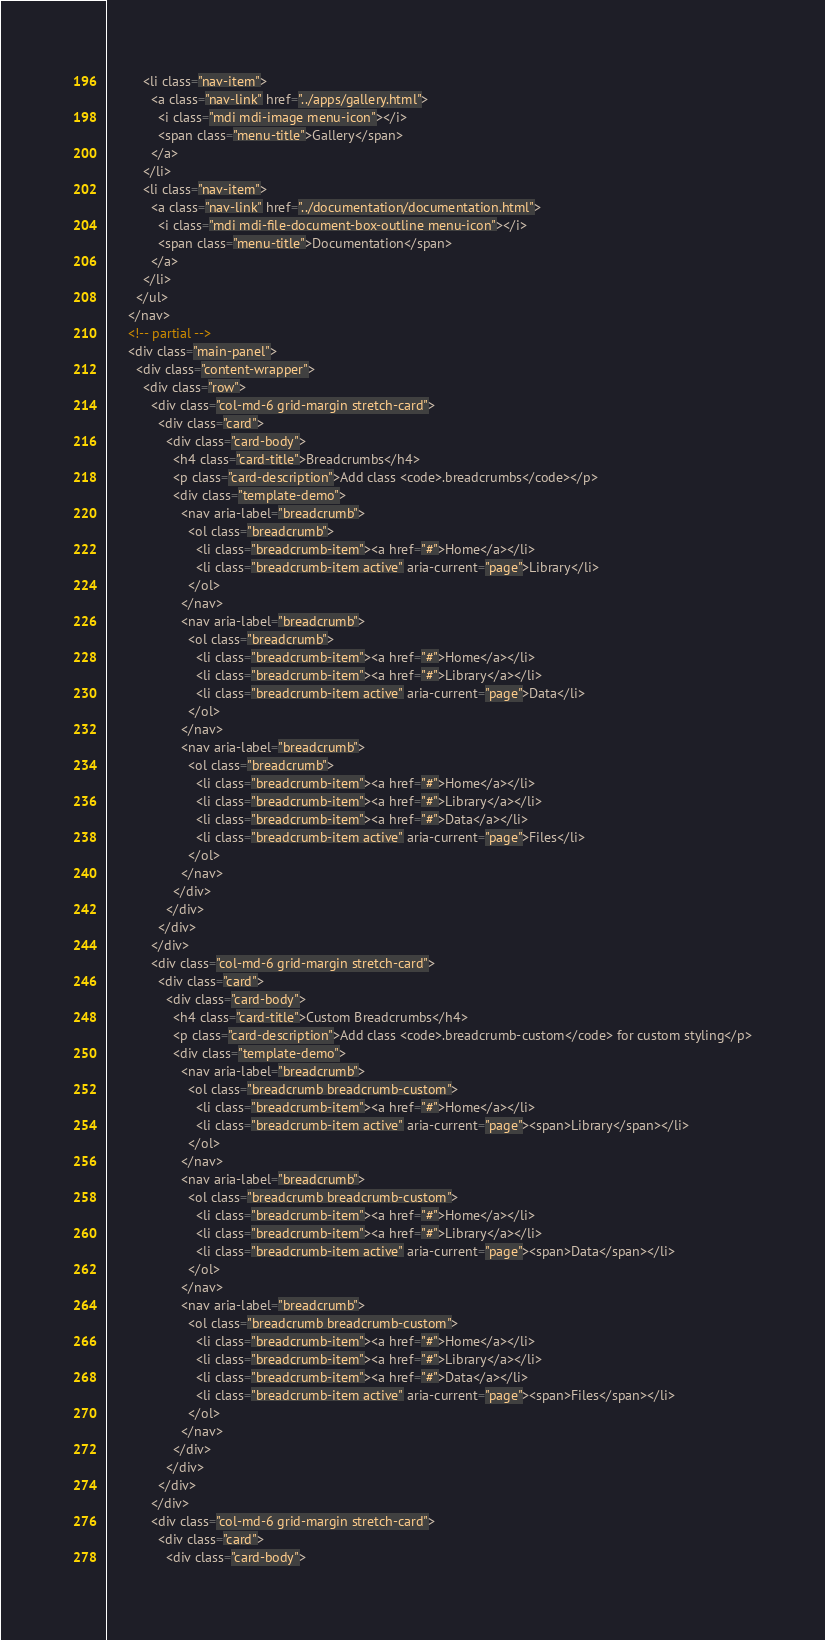Convert code to text. <code><loc_0><loc_0><loc_500><loc_500><_HTML_>          <li class="nav-item">
            <a class="nav-link" href="../apps/gallery.html">
              <i class="mdi mdi-image menu-icon"></i>
              <span class="menu-title">Gallery</span>
            </a>
          </li>
          <li class="nav-item">
            <a class="nav-link" href="../documentation/documentation.html">
              <i class="mdi mdi-file-document-box-outline menu-icon"></i>
              <span class="menu-title">Documentation</span>
            </a>
          </li>
        </ul>
      </nav>
      <!-- partial -->
      <div class="main-panel">          
        <div class="content-wrapper">
          <div class="row">
            <div class="col-md-6 grid-margin stretch-card">
              <div class="card">
                <div class="card-body">
                  <h4 class="card-title">Breadcrumbs</h4>
                  <p class="card-description">Add class <code>.breadcrumbs</code></p>
                  <div class="template-demo">
                    <nav aria-label="breadcrumb">
                      <ol class="breadcrumb">
                        <li class="breadcrumb-item"><a href="#">Home</a></li>
                        <li class="breadcrumb-item active" aria-current="page">Library</li>
                      </ol>
                    </nav>
                    <nav aria-label="breadcrumb">
                      <ol class="breadcrumb">
                        <li class="breadcrumb-item"><a href="#">Home</a></li>
                        <li class="breadcrumb-item"><a href="#">Library</a></li>
                        <li class="breadcrumb-item active" aria-current="page">Data</li>
                      </ol>
                    </nav>
                    <nav aria-label="breadcrumb">
                      <ol class="breadcrumb">
                        <li class="breadcrumb-item"><a href="#">Home</a></li>
                        <li class="breadcrumb-item"><a href="#">Library</a></li>
                        <li class="breadcrumb-item"><a href="#">Data</a></li>
                        <li class="breadcrumb-item active" aria-current="page">Files</li>
                      </ol>
                    </nav>
                  </div>
                </div>
              </div>
            </div>
            <div class="col-md-6 grid-margin stretch-card">
              <div class="card">
                <div class="card-body">
                  <h4 class="card-title">Custom Breadcrumbs</h4>
                  <p class="card-description">Add class <code>.breadcrumb-custom</code> for custom styling</p>
                  <div class="template-demo">
                    <nav aria-label="breadcrumb">
                      <ol class="breadcrumb breadcrumb-custom">
                        <li class="breadcrumb-item"><a href="#">Home</a></li>
                        <li class="breadcrumb-item active" aria-current="page"><span>Library</span></li>
                      </ol>
                    </nav>
                    <nav aria-label="breadcrumb">
                      <ol class="breadcrumb breadcrumb-custom">
                        <li class="breadcrumb-item"><a href="#">Home</a></li>
                        <li class="breadcrumb-item"><a href="#">Library</a></li>
                        <li class="breadcrumb-item active" aria-current="page"><span>Data</span></li>
                      </ol>
                    </nav>
                    <nav aria-label="breadcrumb">
                      <ol class="breadcrumb breadcrumb-custom">
                        <li class="breadcrumb-item"><a href="#">Home</a></li>
                        <li class="breadcrumb-item"><a href="#">Library</a></li>
                        <li class="breadcrumb-item"><a href="#">Data</a></li>
                        <li class="breadcrumb-item active" aria-current="page"><span>Files</span></li>
                      </ol>
                    </nav>
                  </div>
                </div>
              </div>
            </div>
            <div class="col-md-6 grid-margin stretch-card">
              <div class="card">
                <div class="card-body"></code> 